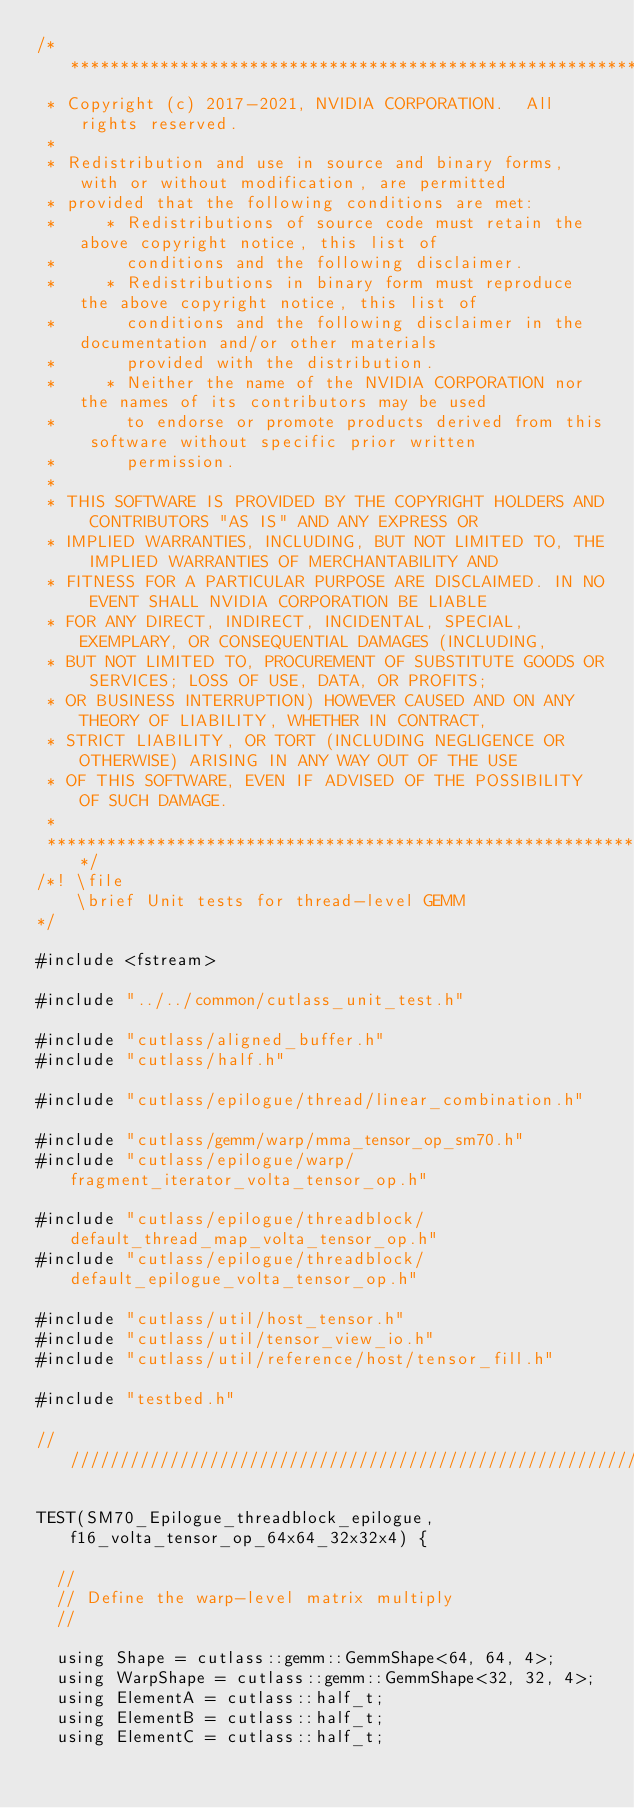Convert code to text. <code><loc_0><loc_0><loc_500><loc_500><_Cuda_>/***************************************************************************************************
 * Copyright (c) 2017-2021, NVIDIA CORPORATION.  All rights reserved.
 *
 * Redistribution and use in source and binary forms, with or without modification, are permitted
 * provided that the following conditions are met:
 *     * Redistributions of source code must retain the above copyright notice, this list of
 *       conditions and the following disclaimer.
 *     * Redistributions in binary form must reproduce the above copyright notice, this list of
 *       conditions and the following disclaimer in the documentation and/or other materials
 *       provided with the distribution.
 *     * Neither the name of the NVIDIA CORPORATION nor the names of its contributors may be used
 *       to endorse or promote products derived from this software without specific prior written
 *       permission.
 *
 * THIS SOFTWARE IS PROVIDED BY THE COPYRIGHT HOLDERS AND CONTRIBUTORS "AS IS" AND ANY EXPRESS OR
 * IMPLIED WARRANTIES, INCLUDING, BUT NOT LIMITED TO, THE IMPLIED WARRANTIES OF MERCHANTABILITY AND
 * FITNESS FOR A PARTICULAR PURPOSE ARE DISCLAIMED. IN NO EVENT SHALL NVIDIA CORPORATION BE LIABLE
 * FOR ANY DIRECT, INDIRECT, INCIDENTAL, SPECIAL, EXEMPLARY, OR CONSEQUENTIAL DAMAGES (INCLUDING,
 * BUT NOT LIMITED TO, PROCUREMENT OF SUBSTITUTE GOODS OR SERVICES; LOSS OF USE, DATA, OR PROFITS;
 * OR BUSINESS INTERRUPTION) HOWEVER CAUSED AND ON ANY THEORY OF LIABILITY, WHETHER IN CONTRACT,
 * STRICT LIABILITY, OR TORT (INCLUDING NEGLIGENCE OR OTHERWISE) ARISING IN ANY WAY OUT OF THE USE
 * OF THIS SOFTWARE, EVEN IF ADVISED OF THE POSSIBILITY OF SUCH DAMAGE.
 *
 **************************************************************************************************/
/*! \file
    \brief Unit tests for thread-level GEMM
*/

#include <fstream>

#include "../../common/cutlass_unit_test.h"

#include "cutlass/aligned_buffer.h"
#include "cutlass/half.h"

#include "cutlass/epilogue/thread/linear_combination.h"

#include "cutlass/gemm/warp/mma_tensor_op_sm70.h"
#include "cutlass/epilogue/warp/fragment_iterator_volta_tensor_op.h"

#include "cutlass/epilogue/threadblock/default_thread_map_volta_tensor_op.h"
#include "cutlass/epilogue/threadblock/default_epilogue_volta_tensor_op.h"

#include "cutlass/util/host_tensor.h"
#include "cutlass/util/tensor_view_io.h"
#include "cutlass/util/reference/host/tensor_fill.h"

#include "testbed.h"

/////////////////////////////////////////////////////////////////////////////////////////////////

TEST(SM70_Epilogue_threadblock_epilogue, f16_volta_tensor_op_64x64_32x32x4) {

  //
  // Define the warp-level matrix multiply
  //

  using Shape = cutlass::gemm::GemmShape<64, 64, 4>;
  using WarpShape = cutlass::gemm::GemmShape<32, 32, 4>;
  using ElementA = cutlass::half_t;
  using ElementB = cutlass::half_t;
  using ElementC = cutlass::half_t;</code> 